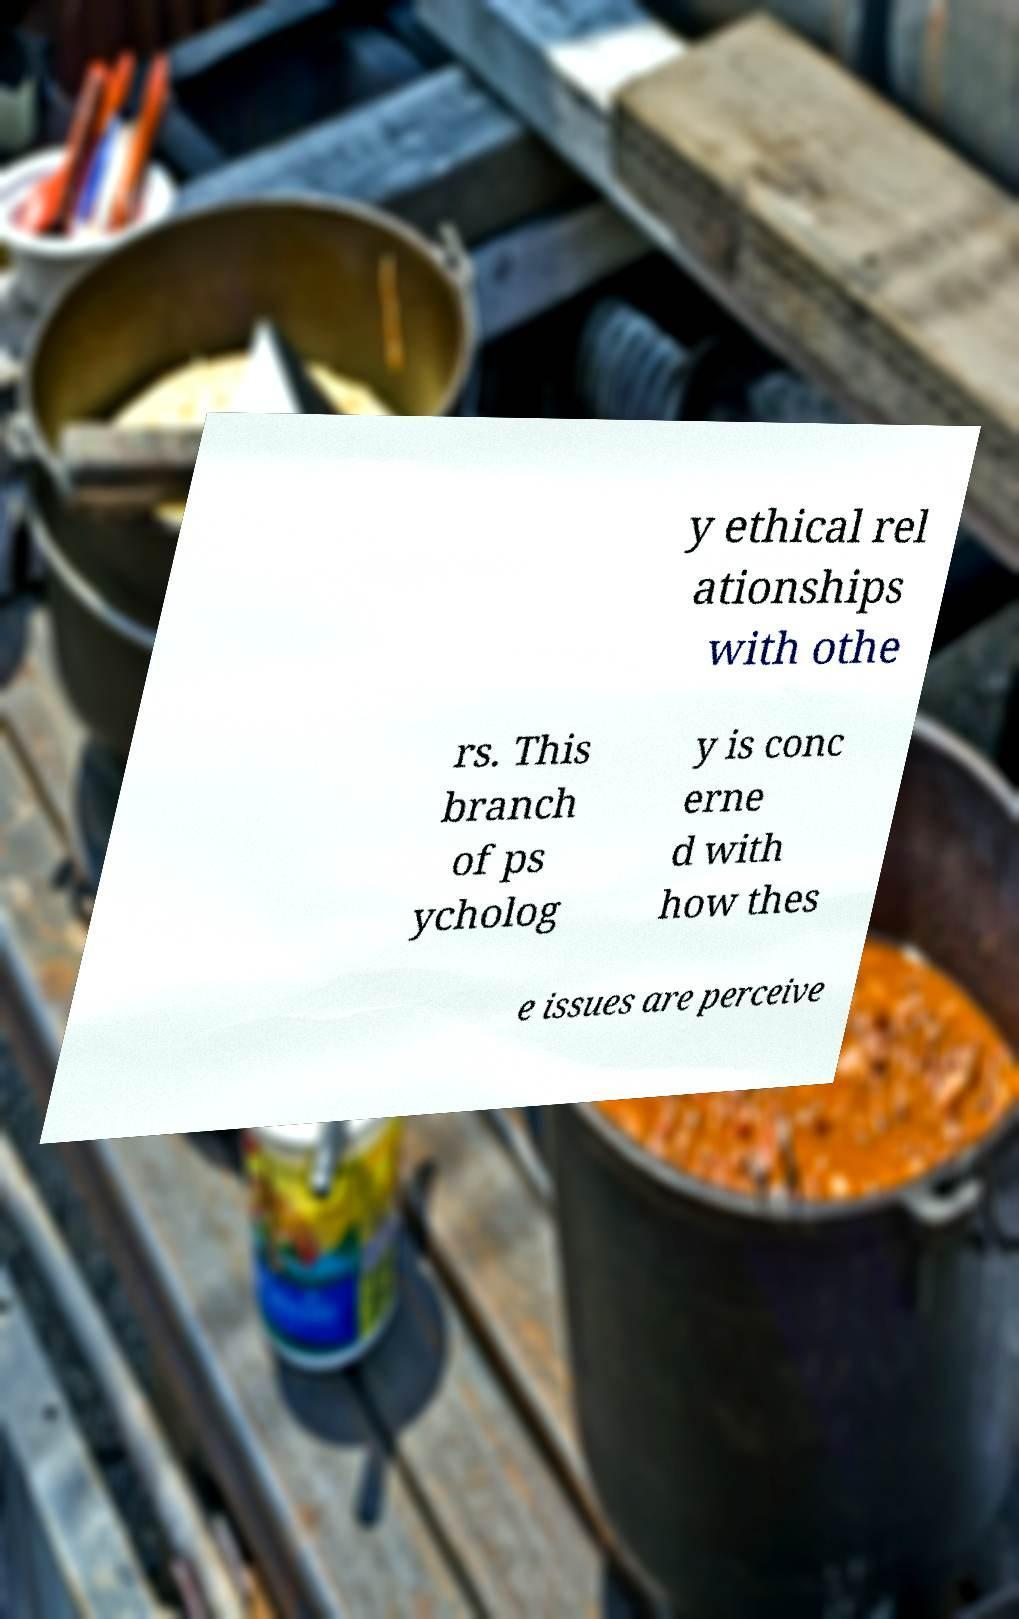Could you assist in decoding the text presented in this image and type it out clearly? y ethical rel ationships with othe rs. This branch of ps ycholog y is conc erne d with how thes e issues are perceive 